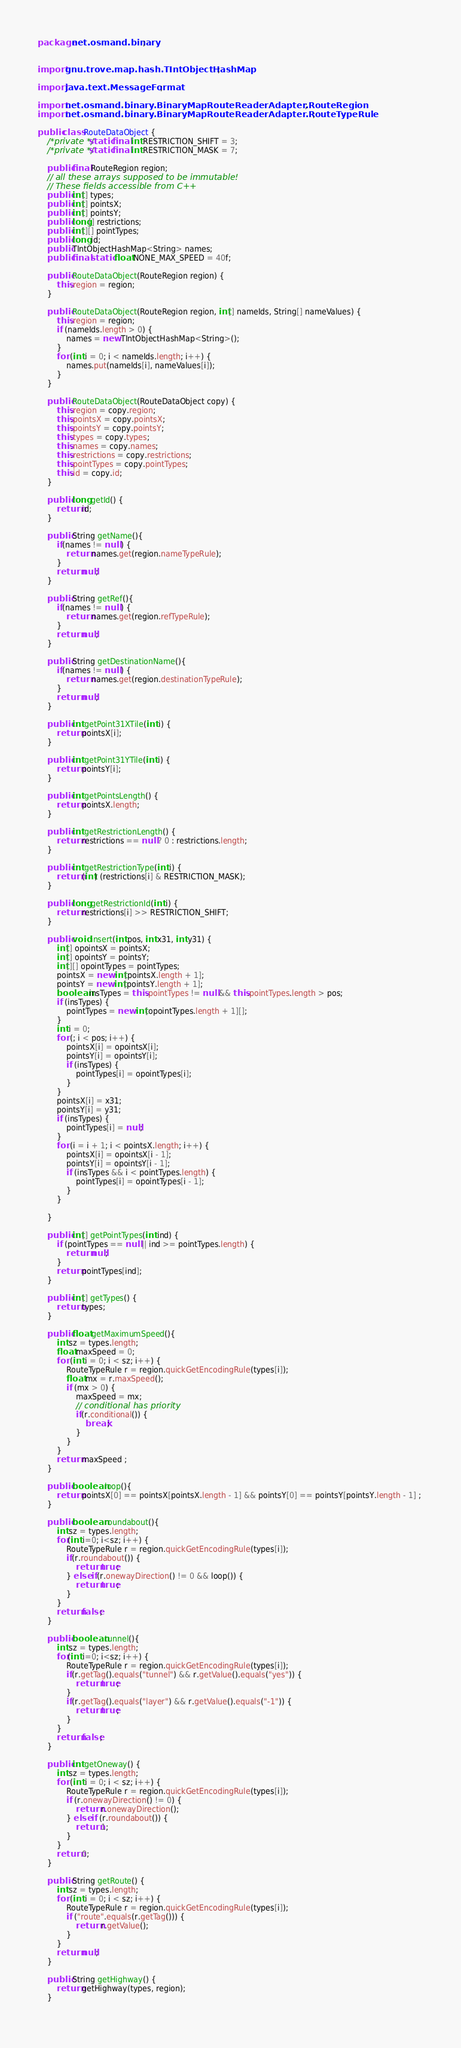Convert code to text. <code><loc_0><loc_0><loc_500><loc_500><_Java_>package net.osmand.binary;


import gnu.trove.map.hash.TIntObjectHashMap;

import java.text.MessageFormat;

import net.osmand.binary.BinaryMapRouteReaderAdapter.RouteRegion;
import net.osmand.binary.BinaryMapRouteReaderAdapter.RouteTypeRule;

public class RouteDataObject {
	/*private */static final int RESTRICTION_SHIFT = 3;
	/*private */static final int RESTRICTION_MASK = 7;
	
	public final RouteRegion region;
	// all these arrays supposed to be immutable!
	// These fields accessible from C++
	public int[] types;
	public int[] pointsX;
	public int[] pointsY;
	public long[] restrictions;
	public int[][] pointTypes;
	public long id;
	public TIntObjectHashMap<String> names;
	public final static float NONE_MAX_SPEED = 40f;
	
	public RouteDataObject(RouteRegion region) {
		this.region = region;
	}
	
	public RouteDataObject(RouteRegion region, int[] nameIds, String[] nameValues) {
		this.region = region;
		if (nameIds.length > 0) {
			names = new TIntObjectHashMap<String>();
		}
		for (int i = 0; i < nameIds.length; i++) {
			names.put(nameIds[i], nameValues[i]);
		}
	}

	public RouteDataObject(RouteDataObject copy) {
		this.region = copy.region;
		this.pointsX = copy.pointsX;
		this.pointsY = copy.pointsY;
		this.types = copy.types;
		this.names = copy.names;
		this.restrictions = copy.restrictions;
		this.pointTypes = copy.pointTypes;
		this.id = copy.id;
	}

	public long getId() {
		return id;
	}
	
	public String getName(){
		if(names != null ) {
			return names.get(region.nameTypeRule);
		}
		return null;
	}
	
	public String getRef(){
		if(names != null ) {
			return names.get(region.refTypeRule);
		}
		return null;
	}

	public String getDestinationName(){
		if(names != null ) {
			return names.get(region.destinationTypeRule);
		}
		return null;
	}
	
	public int getPoint31XTile(int i) {
		return pointsX[i];
	}

	public int getPoint31YTile(int i) {
		return pointsY[i];
	}

	public int getPointsLength() {
		return pointsX.length;
	}

	public int getRestrictionLength() {
		return restrictions == null ? 0 : restrictions.length;
	}

	public int getRestrictionType(int i) {
		return (int) (restrictions[i] & RESTRICTION_MASK);
	}

	public long getRestrictionId(int i) {
		return restrictions[i] >> RESTRICTION_SHIFT;
	}

	public void insert(int pos, int x31, int y31) {
		int[] opointsX = pointsX;
		int[] opointsY = pointsY;
		int[][] opointTypes = pointTypes;
		pointsX = new int[pointsX.length + 1];
		pointsY = new int[pointsY.length + 1];
		boolean insTypes = this.pointTypes != null && this.pointTypes.length > pos;
		if (insTypes) {
			pointTypes = new int[opointTypes.length + 1][];
		}
		int i = 0;
		for (; i < pos; i++) {
			pointsX[i] = opointsX[i];
			pointsY[i] = opointsY[i];
			if (insTypes) {
				pointTypes[i] = opointTypes[i];
			}
		}
		pointsX[i] = x31;
		pointsY[i] = y31;
		if (insTypes) {
			pointTypes[i] = null;
		}
		for (i = i + 1; i < pointsX.length; i++) {
			pointsX[i] = opointsX[i - 1];
			pointsY[i] = opointsY[i - 1];
			if (insTypes && i < pointTypes.length) {
				pointTypes[i] = opointTypes[i - 1];
			}
		}

	}

	public int[] getPointTypes(int ind) {
		if (pointTypes == null || ind >= pointTypes.length) {
			return null;
		}
		return pointTypes[ind];
	}
	
	public int[] getTypes() {
		return types;
	}
	
	public float getMaximumSpeed(){
		int sz = types.length;
        float maxSpeed = 0;
		for (int i = 0; i < sz; i++) {
			RouteTypeRule r = region.quickGetEncodingRule(types[i]);
            float mx = r.maxSpeed();
            if (mx > 0) {
                maxSpeed = mx;
                // conditional has priority
                if(r.conditional()) {
                    break;
                }
            }
		}
		return maxSpeed ;
	}
	
	public boolean loop(){
		return pointsX[0] == pointsX[pointsX.length - 1] && pointsY[0] == pointsY[pointsY.length - 1] ; 
	}
	
	public boolean roundabout(){
		int sz = types.length;
		for(int i=0; i<sz; i++) {
			RouteTypeRule r = region.quickGetEncodingRule(types[i]);
			if(r.roundabout()) {
				return true;
			} else if(r.onewayDirection() != 0 && loop()) {
				return true;
			}
		}
		return false;
	}
	
	public boolean tunnel(){
		int sz = types.length;
		for(int i=0; i<sz; i++) {
			RouteTypeRule r = region.quickGetEncodingRule(types[i]);
			if(r.getTag().equals("tunnel") && r.getValue().equals("yes")) {
				return true;
			}
			if(r.getTag().equals("layer") && r.getValue().equals("-1")) {
				return true;
			}
		}
		return false;
	}
	
	public int getOneway() {
		int sz = types.length;
		for (int i = 0; i < sz; i++) {
			RouteTypeRule r = region.quickGetEncodingRule(types[i]);
			if (r.onewayDirection() != 0) {
				return r.onewayDirection();
			} else if (r.roundabout()) {
				return 1;
			}
		}
		return 0;
	}
	
	public String getRoute() {
		int sz = types.length;
		for (int i = 0; i < sz; i++) {
			RouteTypeRule r = region.quickGetEncodingRule(types[i]);
			if ("route".equals(r.getTag())) {
				return r.getValue();
			}
		}
		return null;
	}

	public String getHighway() {
		return getHighway(types, region);
	}
	</code> 